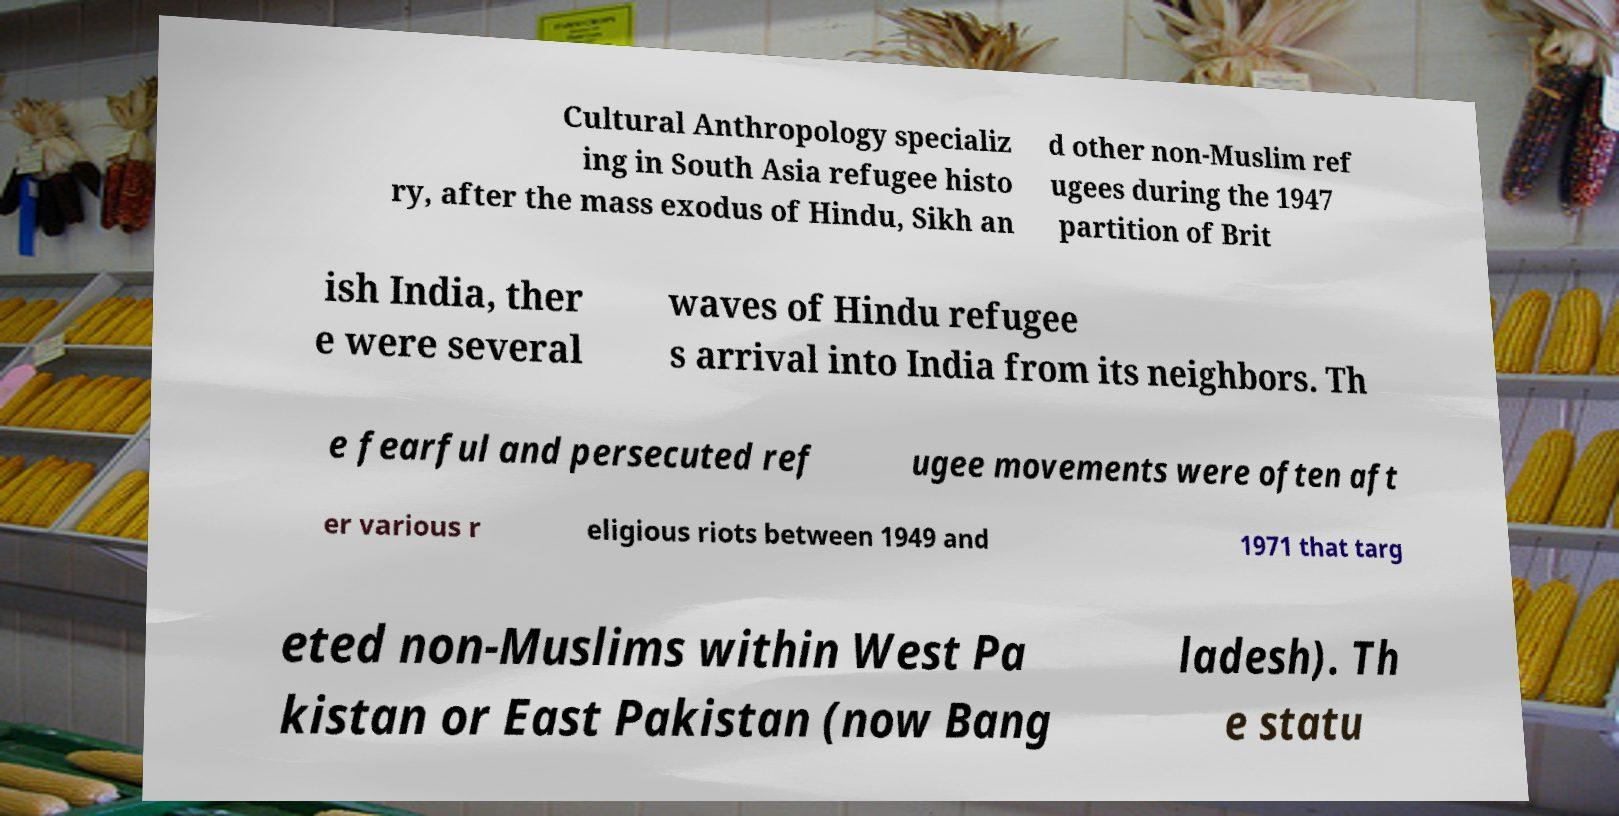What messages or text are displayed in this image? I need them in a readable, typed format. Cultural Anthropology specializ ing in South Asia refugee histo ry, after the mass exodus of Hindu, Sikh an d other non-Muslim ref ugees during the 1947 partition of Brit ish India, ther e were several waves of Hindu refugee s arrival into India from its neighbors. Th e fearful and persecuted ref ugee movements were often aft er various r eligious riots between 1949 and 1971 that targ eted non-Muslims within West Pa kistan or East Pakistan (now Bang ladesh). Th e statu 